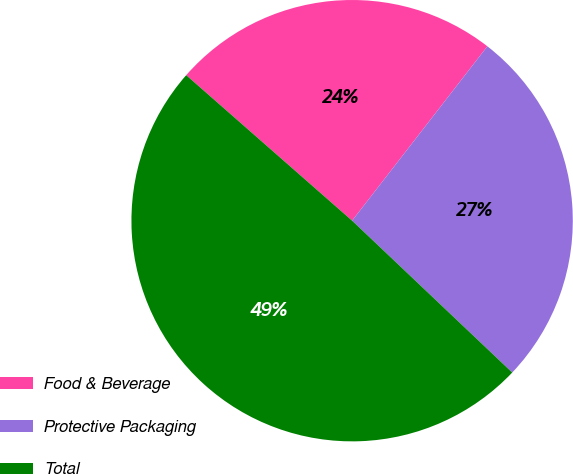<chart> <loc_0><loc_0><loc_500><loc_500><pie_chart><fcel>Food & Beverage<fcel>Protective Packaging<fcel>Total<nl><fcel>24.04%<fcel>26.58%<fcel>49.38%<nl></chart> 